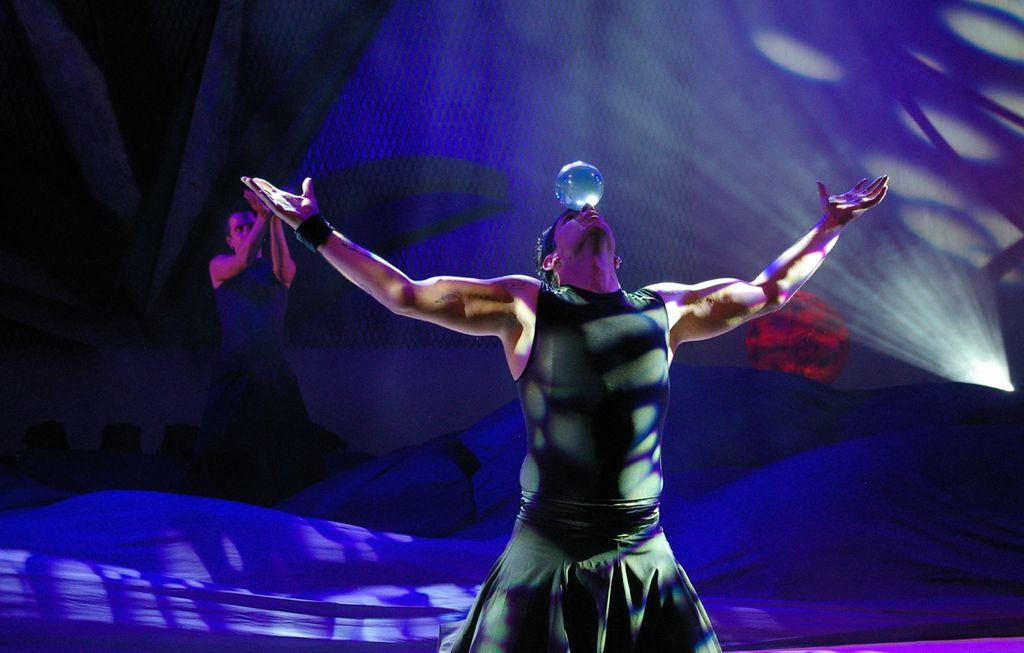What is the most prominent feature of the person in the image? The person in the image has a crystal ball on their forehead. Can you describe the position of the second person in the image? There is another person standing behind the person with the crystal ball. What else can be seen in the background of the image? There are other objects in the background of the image. What type of industry can be seen in the background of the image? There is no industry visible in the background of the image. How many toes are visible on the person with the crystal ball? The number of toes on the person with the crystal ball cannot be determined from the image. 